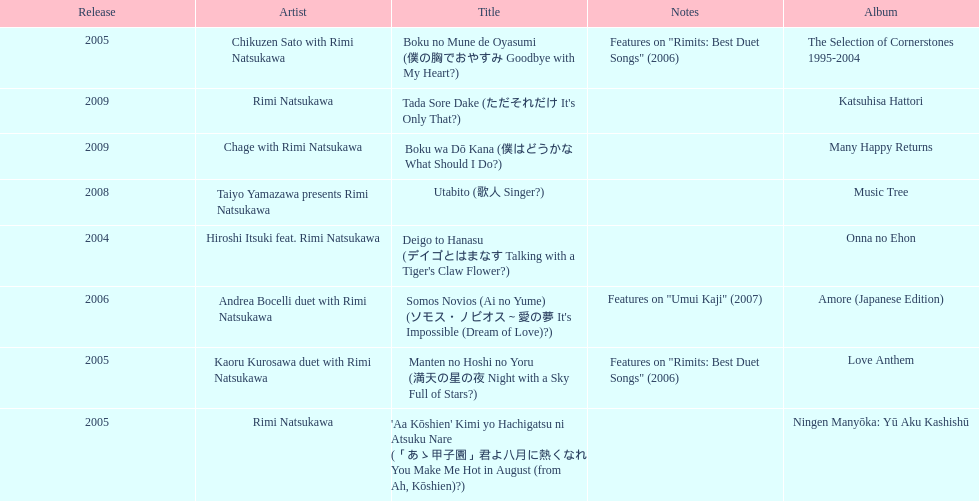What is the last title released? 2009. 